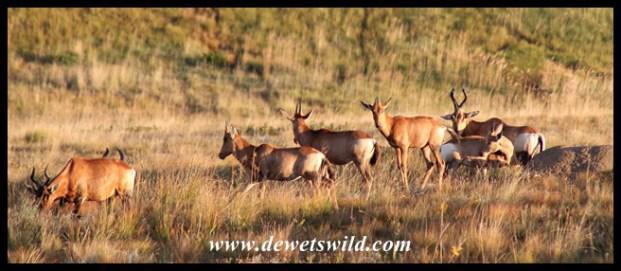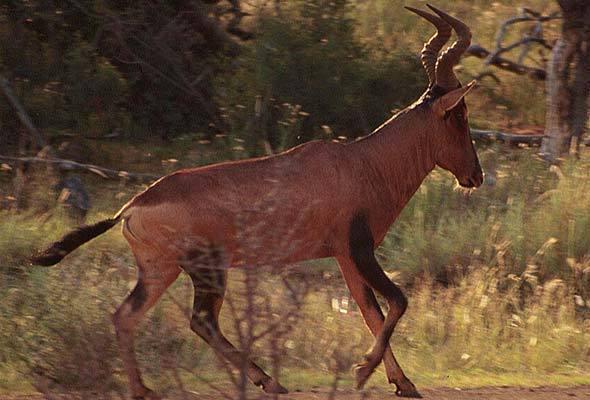The first image is the image on the left, the second image is the image on the right. Considering the images on both sides, is "There are no more than seven animals in the image on the left." valid? Answer yes or no. Yes. The first image is the image on the left, the second image is the image on the right. Analyze the images presented: Is the assertion "There is only one animal in one of the images." valid? Answer yes or no. Yes. The first image is the image on the left, the second image is the image on the right. For the images displayed, is the sentence "An image contains just one horned animal in a field." factually correct? Answer yes or no. Yes. 